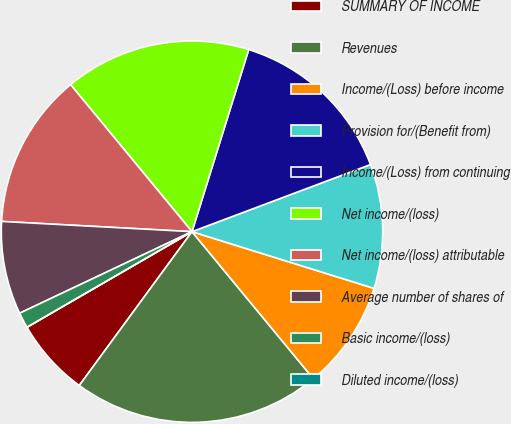Convert chart to OTSL. <chart><loc_0><loc_0><loc_500><loc_500><pie_chart><fcel>SUMMARY OF INCOME<fcel>Revenues<fcel>Income/(Loss) before income<fcel>Provision for/(Benefit from)<fcel>Income/(Loss) from continuing<fcel>Net income/(loss)<fcel>Net income/(loss) attributable<fcel>Average number of shares of<fcel>Basic income/(loss)<fcel>Diluted income/(loss)<nl><fcel>6.58%<fcel>21.05%<fcel>9.21%<fcel>10.53%<fcel>14.47%<fcel>15.79%<fcel>13.16%<fcel>7.89%<fcel>1.32%<fcel>0.0%<nl></chart> 